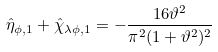<formula> <loc_0><loc_0><loc_500><loc_500>\hat { \eta } _ { \phi , 1 } + \hat { \chi } _ { \lambda \phi , 1 } = - \frac { 1 6 \vartheta ^ { 2 } } { \pi ^ { 2 } ( 1 + \vartheta ^ { 2 } ) ^ { 2 } }</formula> 